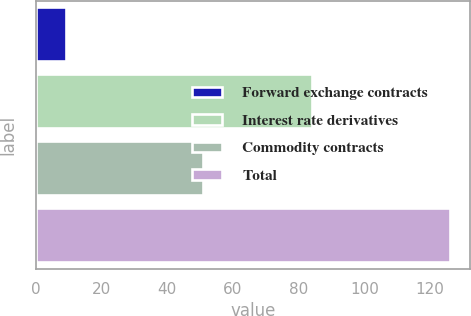<chart> <loc_0><loc_0><loc_500><loc_500><bar_chart><fcel>Forward exchange contracts<fcel>Interest rate derivatives<fcel>Commodity contracts<fcel>Total<nl><fcel>9<fcel>84<fcel>51<fcel>126<nl></chart> 